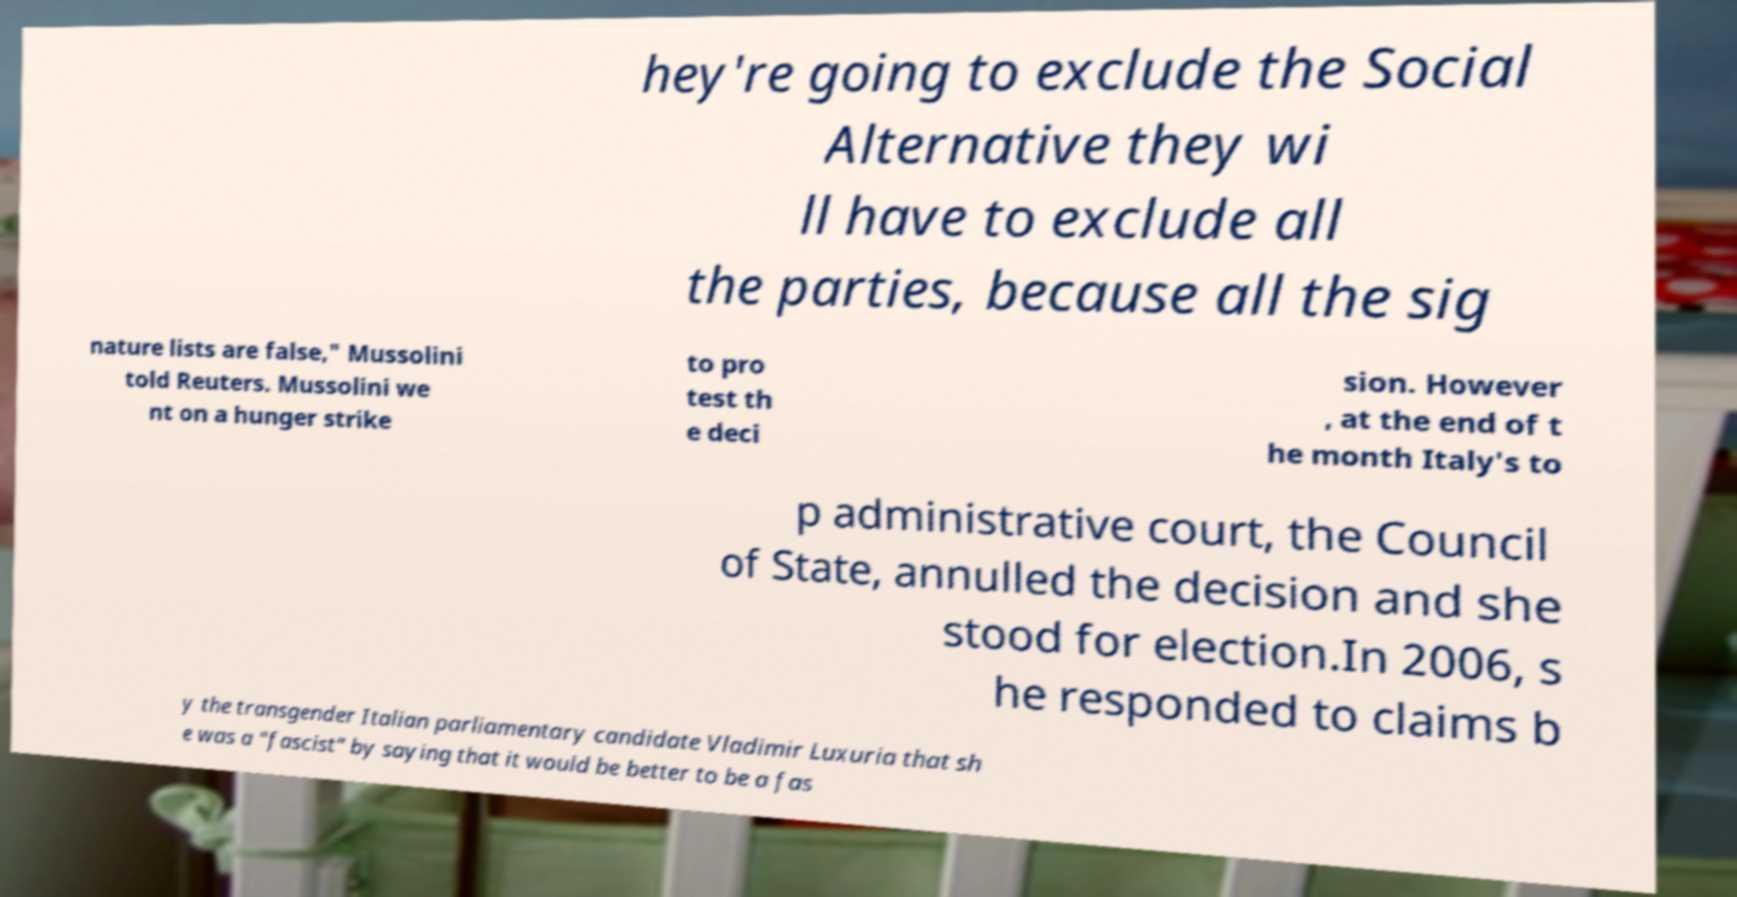For documentation purposes, I need the text within this image transcribed. Could you provide that? hey're going to exclude the Social Alternative they wi ll have to exclude all the parties, because all the sig nature lists are false," Mussolini told Reuters. Mussolini we nt on a hunger strike to pro test th e deci sion. However , at the end of t he month Italy's to p administrative court, the Council of State, annulled the decision and she stood for election.In 2006, s he responded to claims b y the transgender Italian parliamentary candidate Vladimir Luxuria that sh e was a "fascist" by saying that it would be better to be a fas 